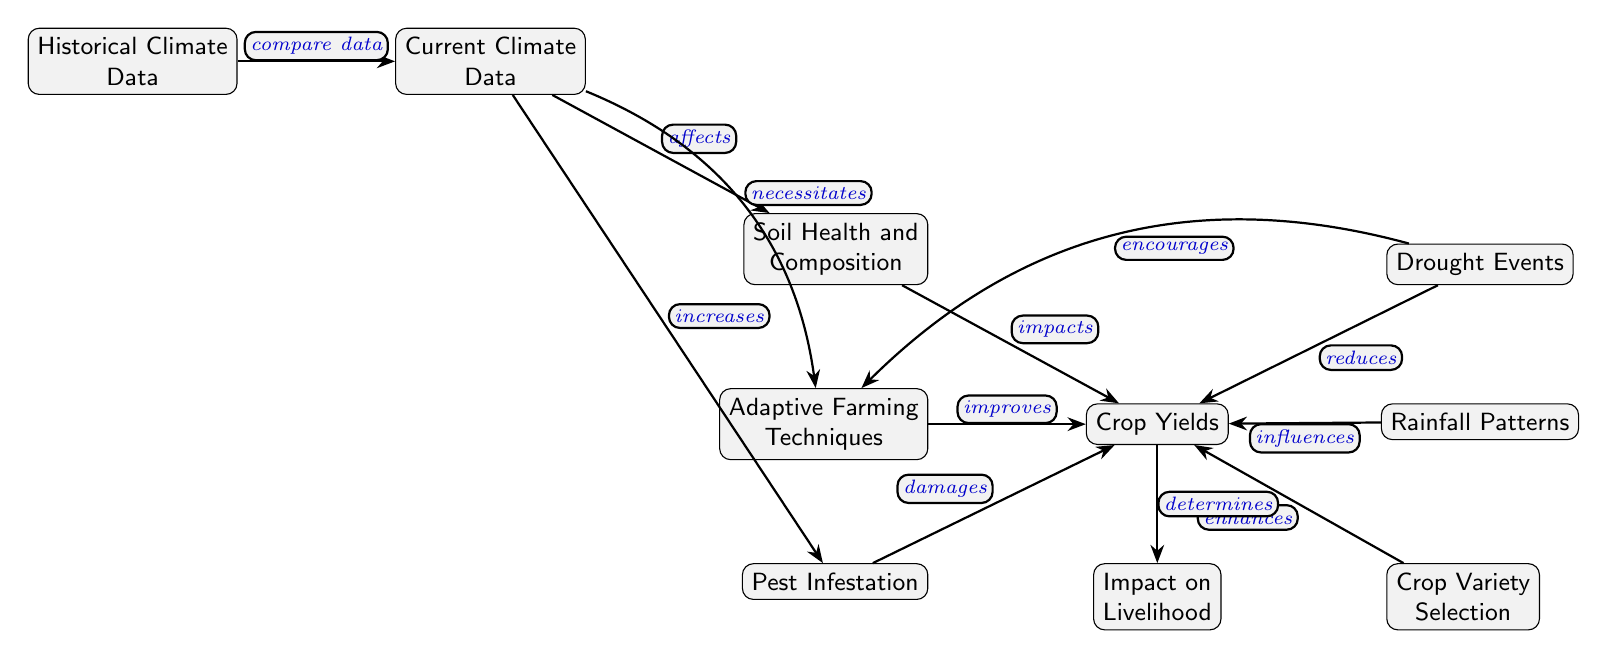What is at the top of the diagram? The top node of the diagram is Historical Climate Data, which represents previous climatic conditions that provide a baseline for comparison with current data.
Answer: Historical Climate Data How many main nodes are in the diagram? There are 9 main nodes listed in the diagram, including Historical Climate Data, Current Climate Data, Soil Health and Composition, Crop Yields, Drought Events, Rainfall Patterns, Pest Infestation, Adaptive Farming Techniques, Crop Variety Selection, and Impact on Livelihood.
Answer: 9 What does Current Climate Data affect? Current Climate Data affects Soil Health and Composition, Crop Yields, Pest Infestation, and necessitates Adaptive Farming Techniques in the diagram's flow.
Answer: Soil Health and Composition Which node shows the effect of climate change on crop viability? Crop Yields is the node that directly represents the impact of various factors influenced by climate change, detailing how these factors affect the viability of farming outputs.
Answer: Crop Yields How does Drought Events influence Crop Yields? Drought Events reduces the Crop Yields, indicating that a lack of rainfall negatively impacts the amount of crops produced, which is depicted as a directed edge in the diagram.
Answer: Reduces What is the relationship between Pest Infestation and Crop Yields? Pest Infestation damages Crop Yields, showing that increased pest issues directly lead to lower crop outputs, supported by the directional flow of the diagram.
Answer: Damages What do Adaptive Farming Techniques do to Crop Yields? Adaptive Farming Techniques improve Crop Yields, indicating that employing better farming practices can counteract some of the negative impacts of climate change on crop production, as expressed in the diagram's flow.
Answer: Improves How do Drought Events and Current Climate Data both connect to Adaptive Farming Techniques? Drought Events encourage Adaptive Farming Techniques by driving the need for improved practices, while Current Climate Data necessitates Adaptive Farming Techniques, indicating two pathways which lead to the same node.
Answer: Encourages and necessitates What is the final consequence shown in the diagram? The final consequence depicted in the diagram is the Impact on Livelihood, which is determined by the overall situation of Crop Yields and associated factors showing the downstream effect of agricultural changes.
Answer: Impact on Livelihood 